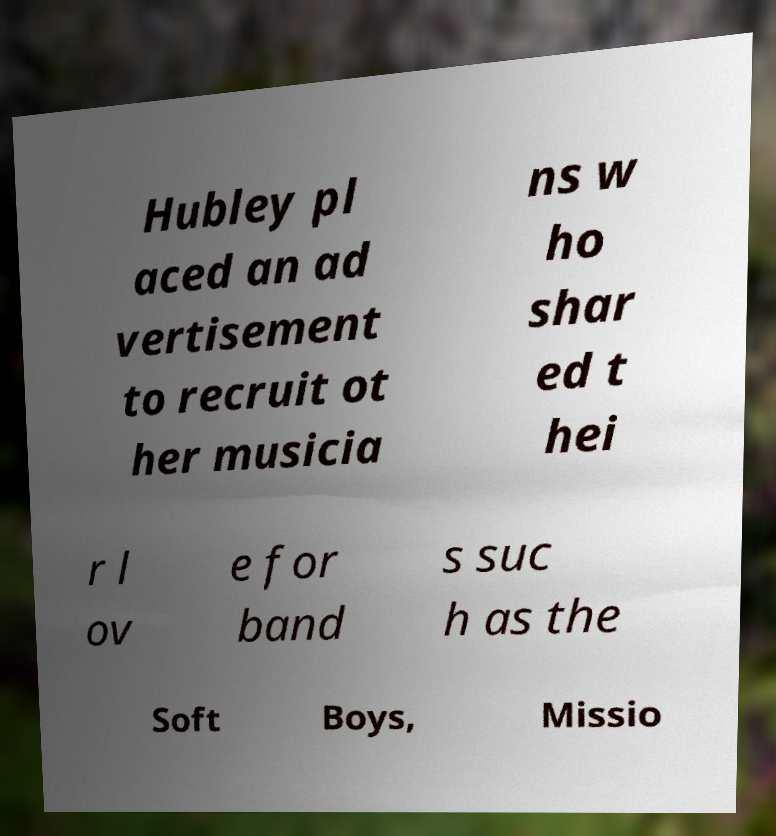I need the written content from this picture converted into text. Can you do that? Hubley pl aced an ad vertisement to recruit ot her musicia ns w ho shar ed t hei r l ov e for band s suc h as the Soft Boys, Missio 